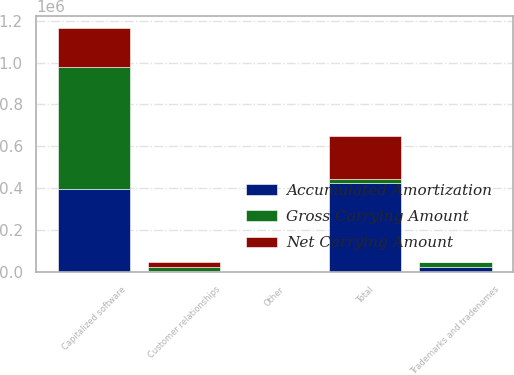Convert chart to OTSL. <chart><loc_0><loc_0><loc_500><loc_500><stacked_bar_chart><ecel><fcel>Capitalized software<fcel>Trademarks and tradenames<fcel>Customer relationships<fcel>Other<fcel>Total<nl><fcel>Gross Carrying Amount<fcel>581874<fcel>22311<fcel>22125<fcel>1803<fcel>22194<nl><fcel>Accumulated Amortization<fcel>397284<fcel>22263<fcel>1988<fcel>803<fcel>422338<nl><fcel>Net Carrying Amount<fcel>184590<fcel>48<fcel>20137<fcel>1000<fcel>205775<nl></chart> 